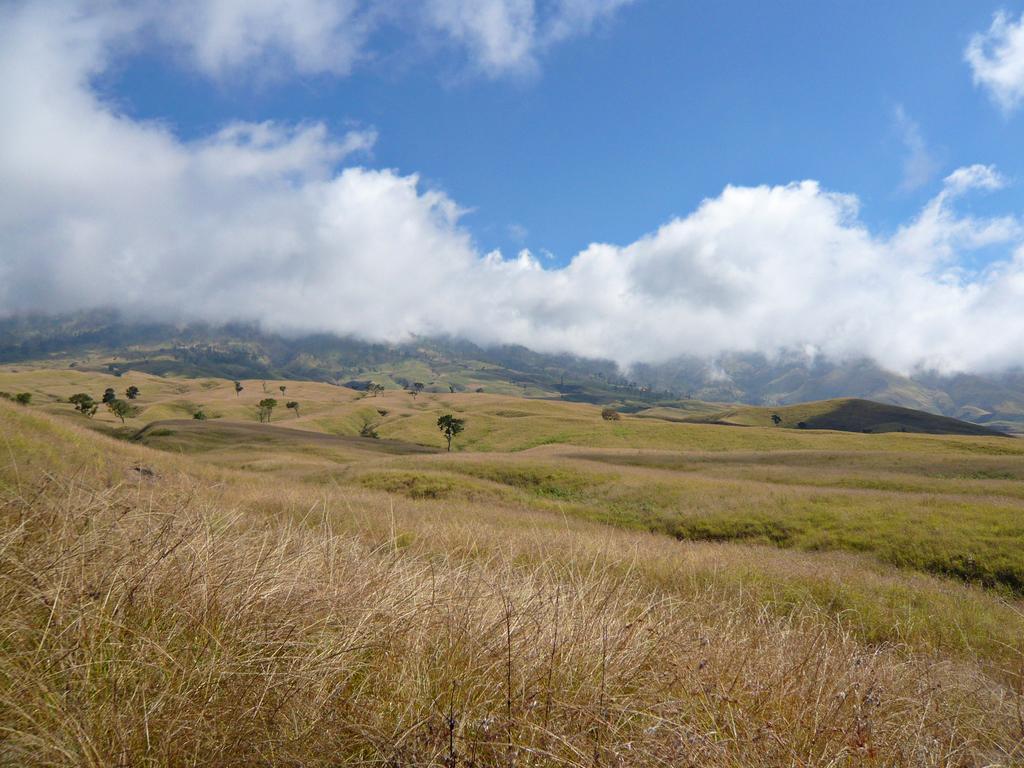Could you give a brief overview of what you see in this image? In this picture we can observe some dried grass on the land. There are some trees. In the background there are hills and a sky with some clouds. 